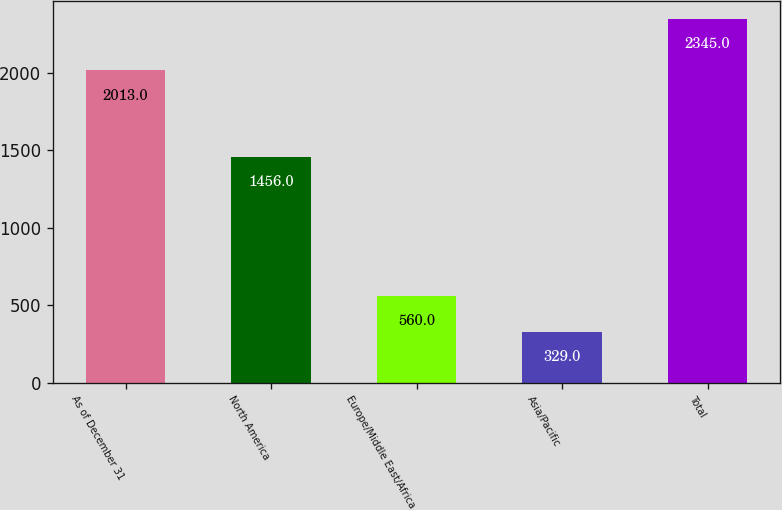Convert chart. <chart><loc_0><loc_0><loc_500><loc_500><bar_chart><fcel>As of December 31<fcel>North America<fcel>Europe/Middle East/Africa<fcel>Asia/Pacific<fcel>Total<nl><fcel>2013<fcel>1456<fcel>560<fcel>329<fcel>2345<nl></chart> 